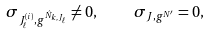Convert formula to latex. <formula><loc_0><loc_0><loc_500><loc_500>\sigma _ { J _ { \ell } ^ { ( i ) } , g ^ { \hat { N } _ { k , J _ { \ell } } } } \neq 0 , \quad \sigma _ { J , g ^ { N ^ { \prime } } } = 0 ,</formula> 